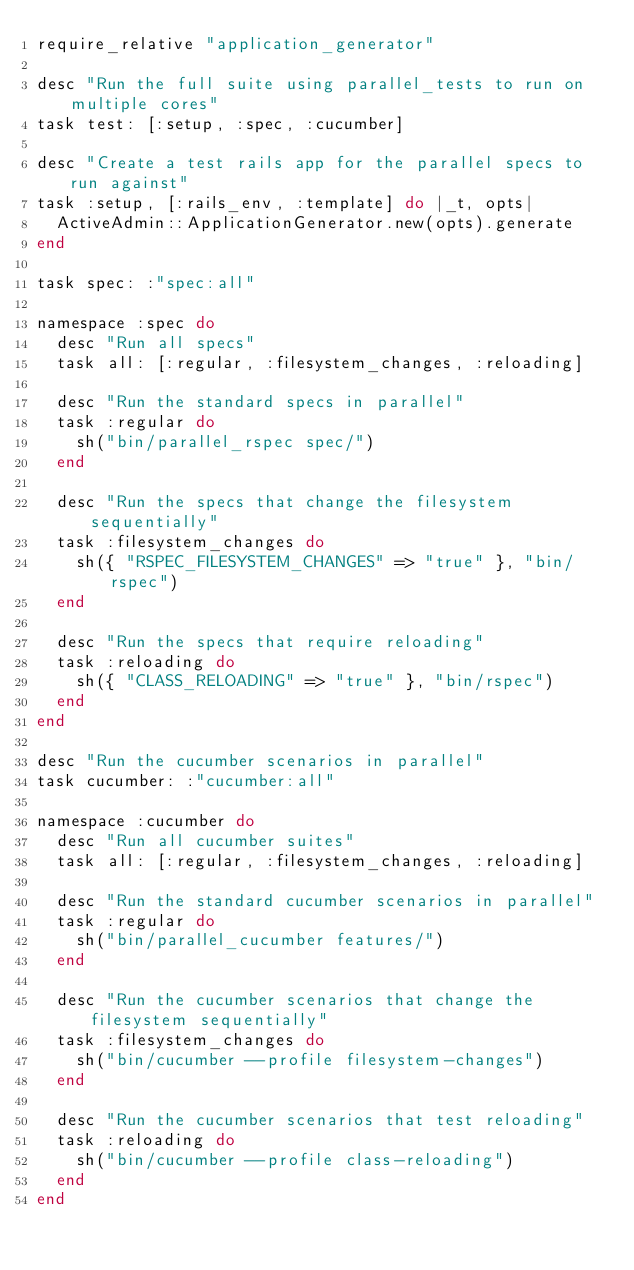Convert code to text. <code><loc_0><loc_0><loc_500><loc_500><_Ruby_>require_relative "application_generator"

desc "Run the full suite using parallel_tests to run on multiple cores"
task test: [:setup, :spec, :cucumber]

desc "Create a test rails app for the parallel specs to run against"
task :setup, [:rails_env, :template] do |_t, opts|
  ActiveAdmin::ApplicationGenerator.new(opts).generate
end

task spec: :"spec:all"

namespace :spec do
  desc "Run all specs"
  task all: [:regular, :filesystem_changes, :reloading]

  desc "Run the standard specs in parallel"
  task :regular do
    sh("bin/parallel_rspec spec/")
  end

  desc "Run the specs that change the filesystem sequentially"
  task :filesystem_changes do
    sh({ "RSPEC_FILESYSTEM_CHANGES" => "true" }, "bin/rspec")
  end

  desc "Run the specs that require reloading"
  task :reloading do
    sh({ "CLASS_RELOADING" => "true" }, "bin/rspec")
  end
end

desc "Run the cucumber scenarios in parallel"
task cucumber: :"cucumber:all"

namespace :cucumber do
  desc "Run all cucumber suites"
  task all: [:regular, :filesystem_changes, :reloading]

  desc "Run the standard cucumber scenarios in parallel"
  task :regular do
    sh("bin/parallel_cucumber features/")
  end

  desc "Run the cucumber scenarios that change the filesystem sequentially"
  task :filesystem_changes do
    sh("bin/cucumber --profile filesystem-changes")
  end

  desc "Run the cucumber scenarios that test reloading"
  task :reloading do
    sh("bin/cucumber --profile class-reloading")
  end
end
</code> 